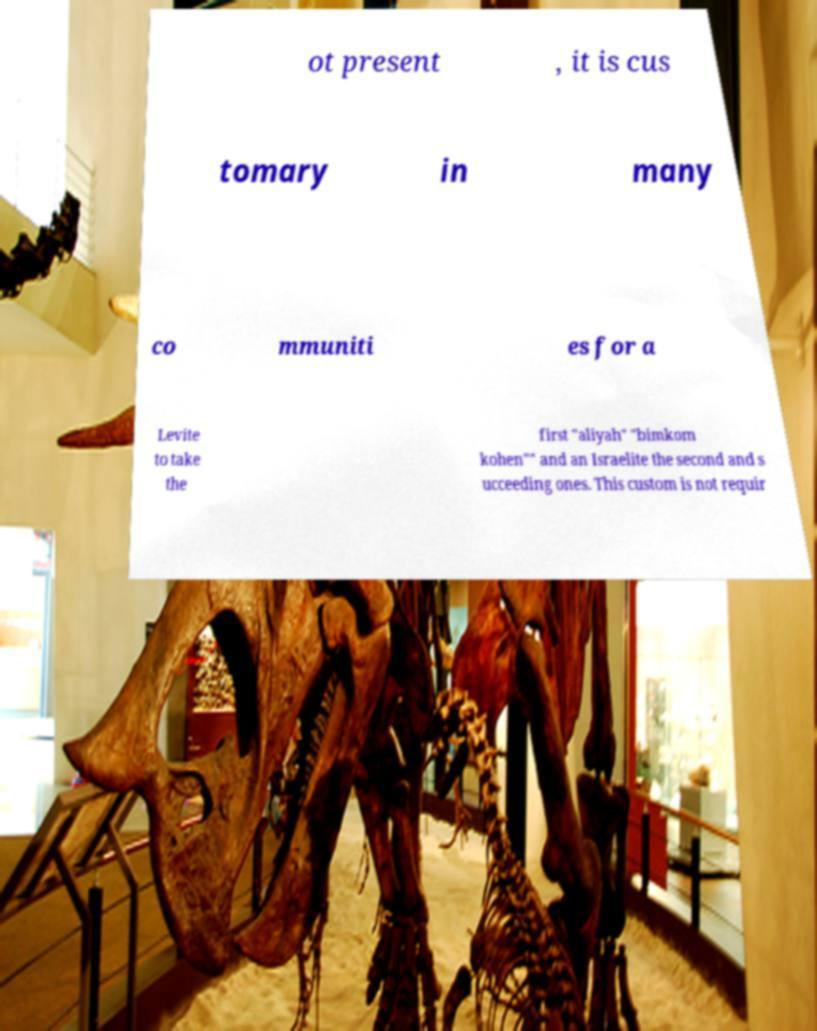For documentation purposes, I need the text within this image transcribed. Could you provide that? ot present , it is cus tomary in many co mmuniti es for a Levite to take the first "aliyah" "bimkom kohen"" and an Israelite the second and s ucceeding ones. This custom is not requir 